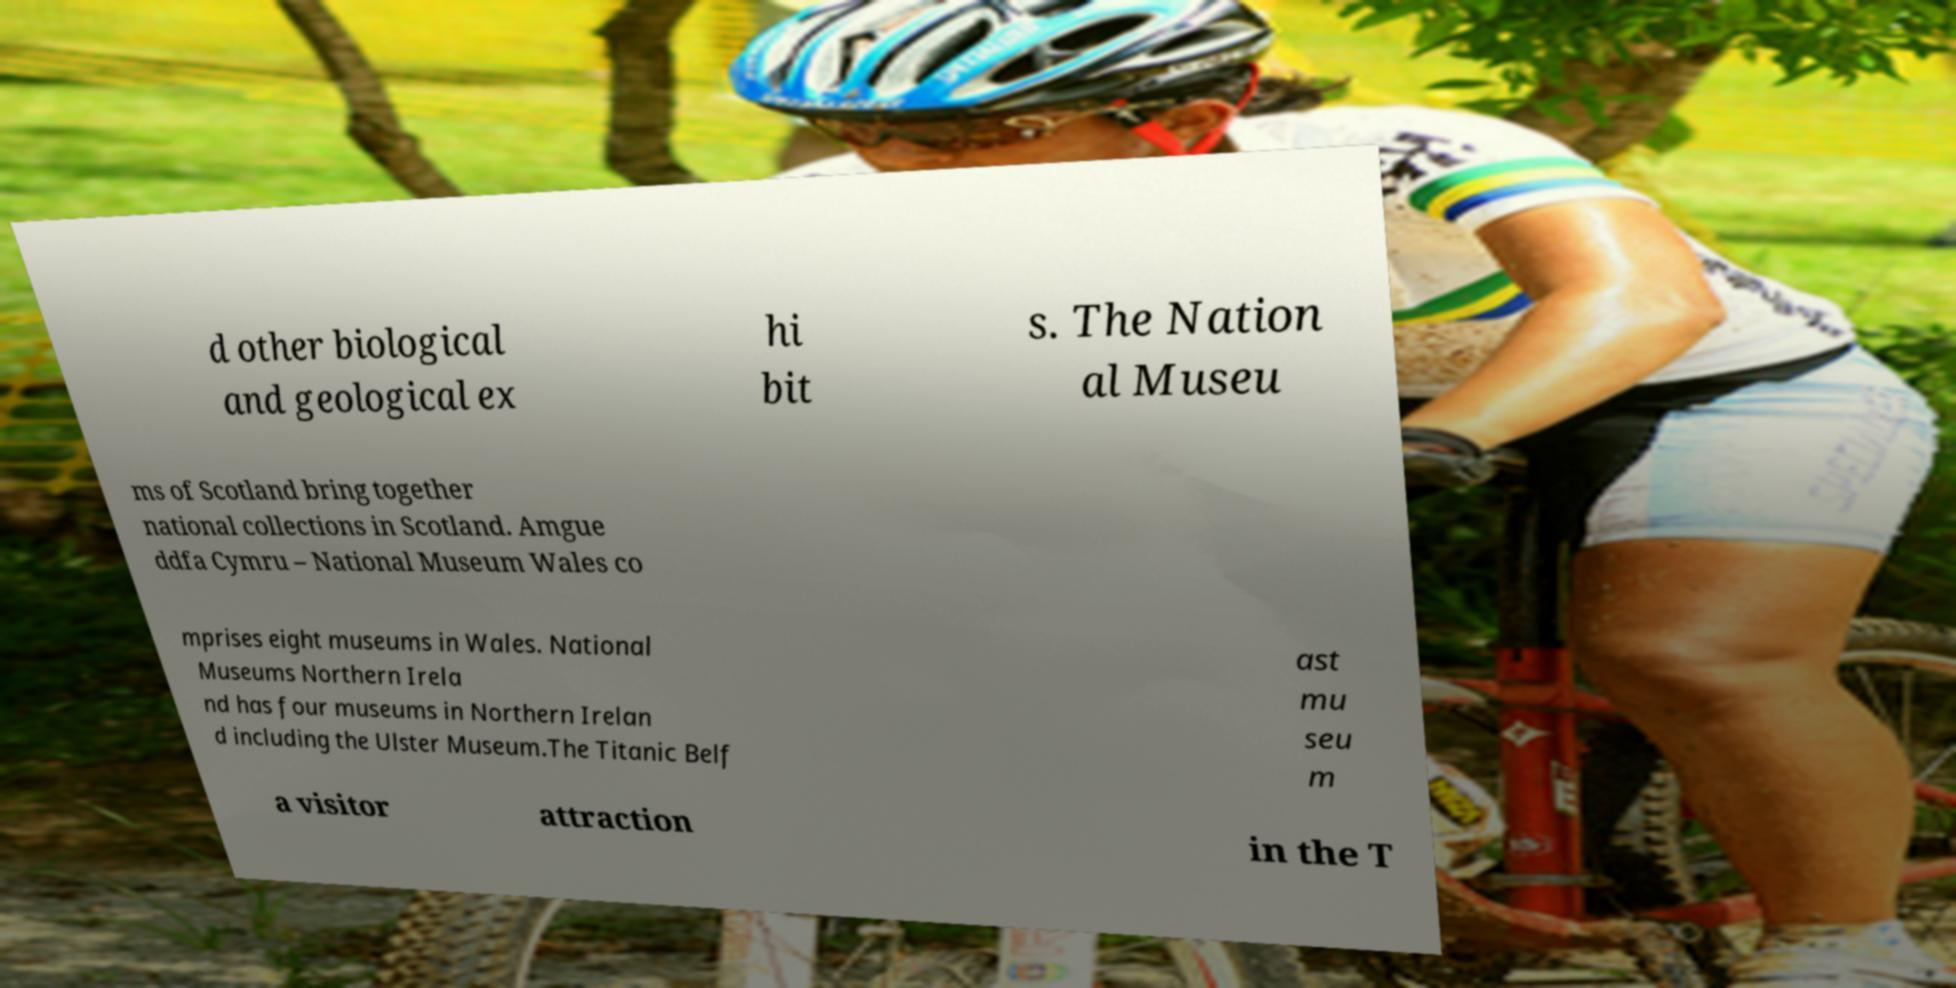There's text embedded in this image that I need extracted. Can you transcribe it verbatim? d other biological and geological ex hi bit s. The Nation al Museu ms of Scotland bring together national collections in Scotland. Amgue ddfa Cymru – National Museum Wales co mprises eight museums in Wales. National Museums Northern Irela nd has four museums in Northern Irelan d including the Ulster Museum.The Titanic Belf ast mu seu m a visitor attraction in the T 